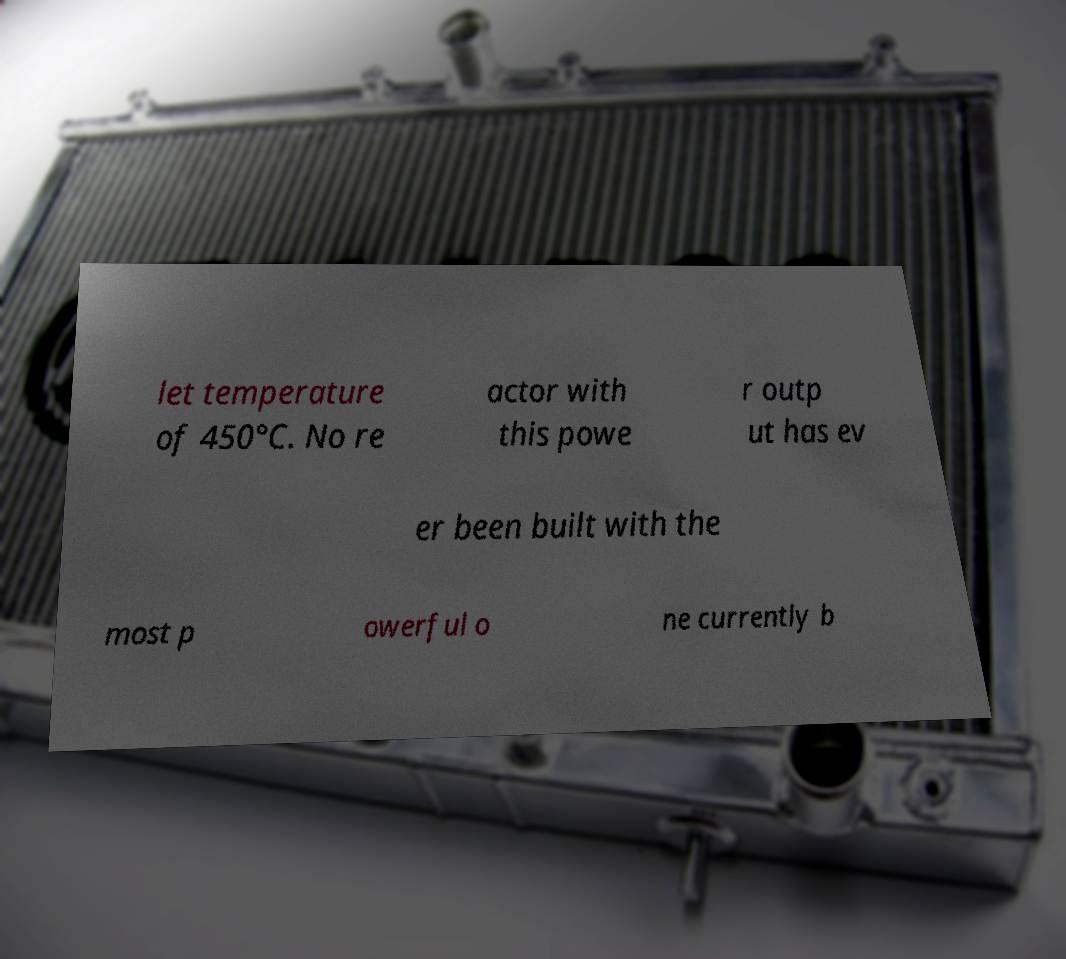Please identify and transcribe the text found in this image. let temperature of 450°C. No re actor with this powe r outp ut has ev er been built with the most p owerful o ne currently b 